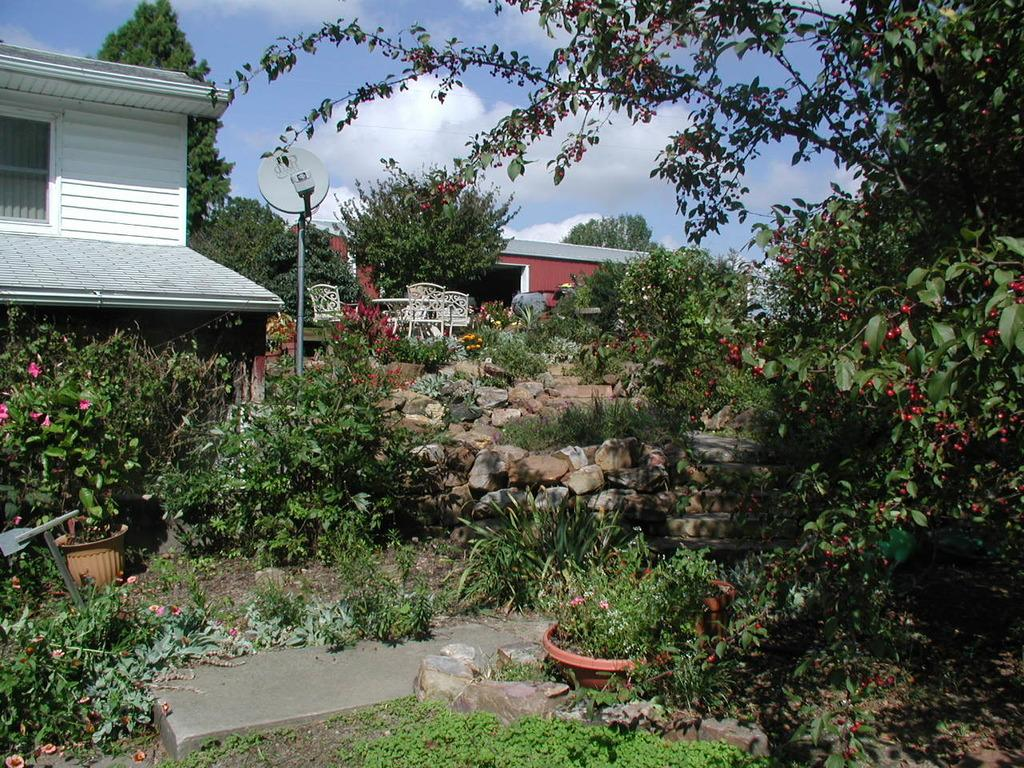What type of vegetation can be seen in the image? There are plants and trees in the image. What objects are used to hold the plants? There are flower pots in the image. What type of material is present in the image? There are stones in the image. What type of structures can be seen in the image? There are houses in the image. What can be seen in the background of the image? There are trees and a clear sky in the background of the image. What type of jam is being spread on the glove in the image? There is no glove or jam present in the image. How does the coastline appear in the image? There is no coastline present in the image. 